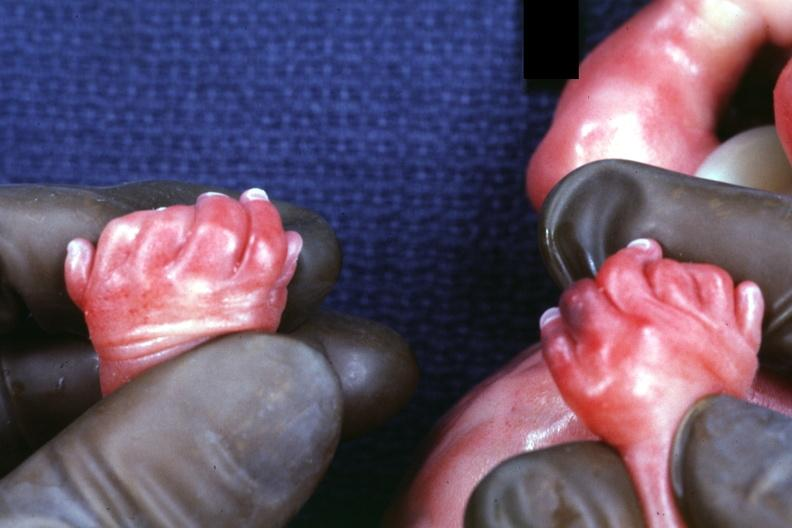s hand present?
Answer the question using a single word or phrase. Yes 